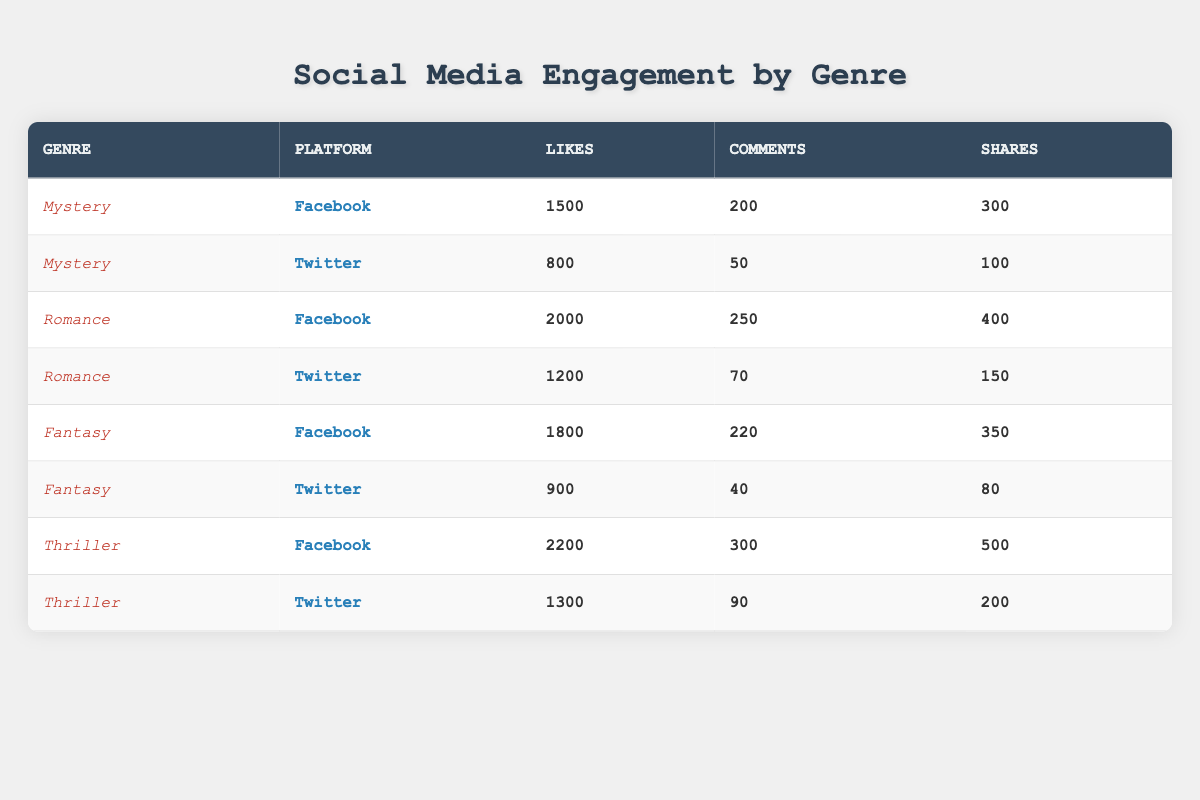What genre has the highest number of likes on Facebook? By examining the row for each genre under Facebook, the Thriller genre has the highest likes at 2200.
Answer: Thriller Which platform received the most shares for the Romance genre? Looking at the Romance genre across both platforms, Facebook has 400 shares, which is higher than the 150 shares on Twitter.
Answer: Facebook What is the total number of comments for the Fantasy genre across both platforms? The total number of comments for Fantasy on Facebook is 220 and on Twitter is 40. Summing these gives 220 + 40 = 260 comments.
Answer: 260 Is it true that the Mystery genre has more likes on Twitter than the Fantasy genre? The Mystery genre has 800 likes on Twitter, while the Fantasy genre has 900 likes on Twitter. Therefore, this statement is false.
Answer: No What is the average number of shares for the Thriller genre? For the Thriller genre, there are 500 shares on Facebook and 200 shares on Twitter. The total number of shares is 500 + 200 = 700. Dividing by the number of platforms (2) gives an average of 700 / 2 = 350.
Answer: 350 Which genre generally has higher engagement on social media, Mystery or Romance? By comparing total engagement metrics, Romance has 2000 likes plus 250 comments plus 400 shares on Facebook and 1200 likes plus 70 comments plus 150 shares on Twitter. Mystery has 1500 + 200 + 300 on Facebook and 800 + 50 + 100 on Twitter. The total engagement for Romance is 3920 and for Mystery is 2150. Romance generally has higher engagement.
Answer: Romance What is the difference in likes between the best-performing platform for each genre? The best likes are on Facebook for all genres except Mystery. For Mystery, it's 1500 on Facebook versus 800 on Twitter, a difference of 700. For Romance, it’s 2000 on Facebook minus 1200 on Twitter equals 800. For Fantasy, it's 1800 on Facebook minus 900 on Twitter equals 900. For Thriller, it’s 2200 on Facebook minus 1300 on Twitter equals 900. Thus, the differences are 700, 800, 900, and 900 respectively.
Answer: 900 Which genre has the most total likes across both platforms? Calculating the total likes, we have 1500 (Mystery Facebook) + 800 (Mystery Twitter) + 2000 (Romance Facebook) + 1200 (Romance Twitter) + 1800 (Fantasy Facebook) + 900 (Fantasy Twitter) + 2200 (Thriller Facebook) + 1300 (Thriller Twitter). This totals to 10200 likes. The highest is Romance with 3200.
Answer: Romance 